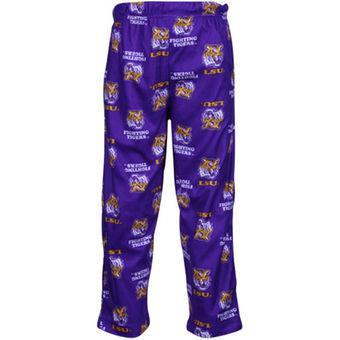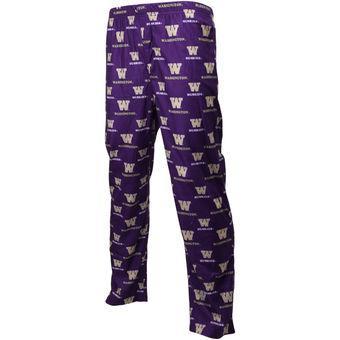The first image is the image on the left, the second image is the image on the right. For the images displayed, is the sentence "at least one pair of pants is worn by a human." factually correct? Answer yes or no. No. 